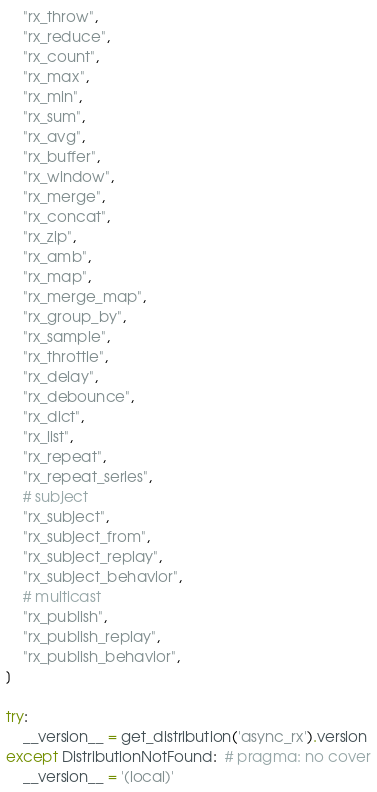<code> <loc_0><loc_0><loc_500><loc_500><_Python_>    "rx_throw",
    "rx_reduce",
    "rx_count",
    "rx_max",
    "rx_min",
    "rx_sum",
    "rx_avg",
    "rx_buffer",
    "rx_window",
    "rx_merge",
    "rx_concat",
    "rx_zip",
    "rx_amb",
    "rx_map",
    "rx_merge_map",
    "rx_group_by",
    "rx_sample",
    "rx_throttle",
    "rx_delay",
    "rx_debounce",
    "rx_dict",
    "rx_list",
    "rx_repeat",
    "rx_repeat_series",
    # subject
    "rx_subject",
    "rx_subject_from",
    "rx_subject_replay",
    "rx_subject_behavior",
    # multicast
    "rx_publish",
    "rx_publish_replay",
    "rx_publish_behavior",
]

try:
    __version__ = get_distribution('async_rx').version
except DistributionNotFound:  # pragma: no cover
    __version__ = '(local)'
</code> 